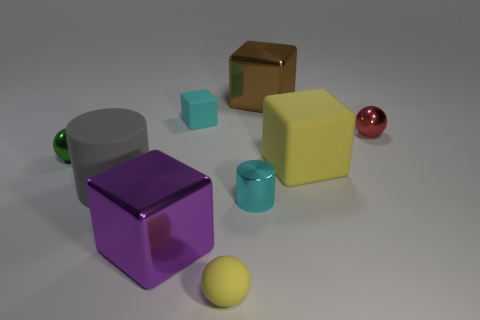Subtract all metallic balls. How many balls are left? 1 Subtract all brown cubes. How many cubes are left? 3 Subtract 3 cubes. How many cubes are left? 1 Add 1 small brown matte spheres. How many objects exist? 10 Subtract all cubes. How many objects are left? 5 Subtract all gray cubes. Subtract all red cylinders. How many cubes are left? 4 Subtract all cyan balls. How many cyan cylinders are left? 1 Subtract all tiny cylinders. Subtract all rubber cubes. How many objects are left? 6 Add 3 big gray cylinders. How many big gray cylinders are left? 4 Add 1 tiny matte things. How many tiny matte things exist? 3 